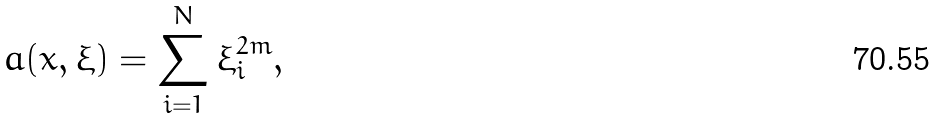<formula> <loc_0><loc_0><loc_500><loc_500>a ( x , \xi ) = \sum _ { i = 1 } ^ { N } \xi _ { i } ^ { 2 m } ,</formula> 